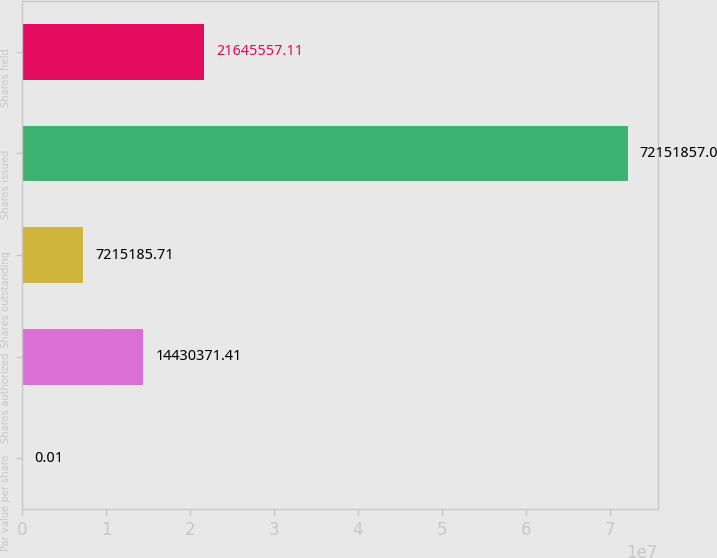Convert chart to OTSL. <chart><loc_0><loc_0><loc_500><loc_500><bar_chart><fcel>Par value per share<fcel>Shares authorized<fcel>Shares outstanding<fcel>Shares issued<fcel>Shares held<nl><fcel>0.01<fcel>1.44304e+07<fcel>7.21519e+06<fcel>7.21519e+07<fcel>2.16456e+07<nl></chart> 